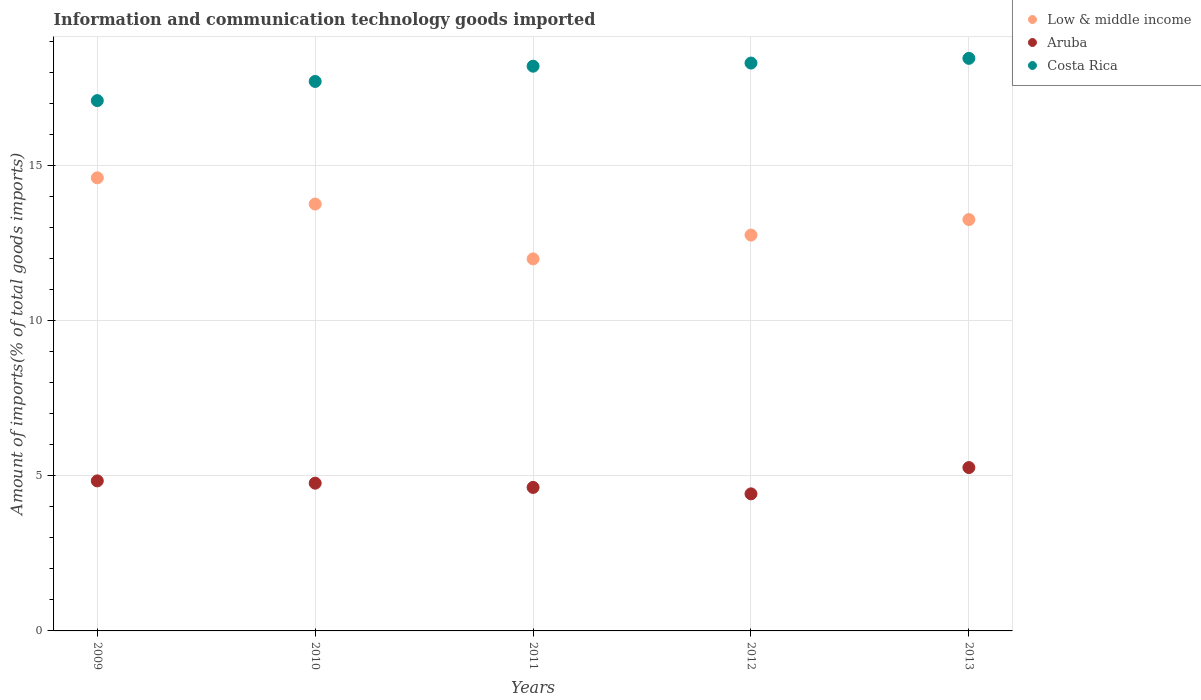How many different coloured dotlines are there?
Offer a very short reply. 3. Is the number of dotlines equal to the number of legend labels?
Your response must be concise. Yes. What is the amount of goods imported in Low & middle income in 2011?
Provide a succinct answer. 12. Across all years, what is the maximum amount of goods imported in Low & middle income?
Ensure brevity in your answer.  14.61. Across all years, what is the minimum amount of goods imported in Low & middle income?
Keep it short and to the point. 12. What is the total amount of goods imported in Aruba in the graph?
Your answer should be compact. 23.92. What is the difference between the amount of goods imported in Costa Rica in 2012 and that in 2013?
Provide a succinct answer. -0.15. What is the difference between the amount of goods imported in Low & middle income in 2011 and the amount of goods imported in Costa Rica in 2010?
Keep it short and to the point. -5.72. What is the average amount of goods imported in Aruba per year?
Provide a short and direct response. 4.78. In the year 2011, what is the difference between the amount of goods imported in Costa Rica and amount of goods imported in Low & middle income?
Your response must be concise. 6.21. In how many years, is the amount of goods imported in Low & middle income greater than 6 %?
Your response must be concise. 5. What is the ratio of the amount of goods imported in Low & middle income in 2009 to that in 2013?
Make the answer very short. 1.1. What is the difference between the highest and the second highest amount of goods imported in Costa Rica?
Your answer should be very brief. 0.15. What is the difference between the highest and the lowest amount of goods imported in Low & middle income?
Ensure brevity in your answer.  2.61. In how many years, is the amount of goods imported in Aruba greater than the average amount of goods imported in Aruba taken over all years?
Offer a terse response. 2. Is the sum of the amount of goods imported in Aruba in 2009 and 2010 greater than the maximum amount of goods imported in Costa Rica across all years?
Keep it short and to the point. No. Does the amount of goods imported in Low & middle income monotonically increase over the years?
Offer a very short reply. No. What is the difference between two consecutive major ticks on the Y-axis?
Make the answer very short. 5. Does the graph contain any zero values?
Your answer should be very brief. No. Does the graph contain grids?
Offer a terse response. Yes. Where does the legend appear in the graph?
Your response must be concise. Top right. What is the title of the graph?
Ensure brevity in your answer.  Information and communication technology goods imported. What is the label or title of the Y-axis?
Your response must be concise. Amount of imports(% of total goods imports). What is the Amount of imports(% of total goods imports) of Low & middle income in 2009?
Your response must be concise. 14.61. What is the Amount of imports(% of total goods imports) in Aruba in 2009?
Your response must be concise. 4.84. What is the Amount of imports(% of total goods imports) of Costa Rica in 2009?
Your response must be concise. 17.1. What is the Amount of imports(% of total goods imports) in Low & middle income in 2010?
Your answer should be compact. 13.77. What is the Amount of imports(% of total goods imports) of Aruba in 2010?
Your answer should be compact. 4.76. What is the Amount of imports(% of total goods imports) of Costa Rica in 2010?
Ensure brevity in your answer.  17.72. What is the Amount of imports(% of total goods imports) of Low & middle income in 2011?
Your answer should be very brief. 12. What is the Amount of imports(% of total goods imports) of Aruba in 2011?
Your answer should be compact. 4.63. What is the Amount of imports(% of total goods imports) of Costa Rica in 2011?
Your answer should be compact. 18.21. What is the Amount of imports(% of total goods imports) of Low & middle income in 2012?
Your answer should be very brief. 12.77. What is the Amount of imports(% of total goods imports) in Aruba in 2012?
Your answer should be compact. 4.42. What is the Amount of imports(% of total goods imports) of Costa Rica in 2012?
Your answer should be compact. 18.31. What is the Amount of imports(% of total goods imports) in Low & middle income in 2013?
Give a very brief answer. 13.27. What is the Amount of imports(% of total goods imports) in Aruba in 2013?
Make the answer very short. 5.27. What is the Amount of imports(% of total goods imports) of Costa Rica in 2013?
Keep it short and to the point. 18.47. Across all years, what is the maximum Amount of imports(% of total goods imports) of Low & middle income?
Your response must be concise. 14.61. Across all years, what is the maximum Amount of imports(% of total goods imports) of Aruba?
Your answer should be compact. 5.27. Across all years, what is the maximum Amount of imports(% of total goods imports) in Costa Rica?
Your response must be concise. 18.47. Across all years, what is the minimum Amount of imports(% of total goods imports) in Low & middle income?
Make the answer very short. 12. Across all years, what is the minimum Amount of imports(% of total goods imports) of Aruba?
Ensure brevity in your answer.  4.42. Across all years, what is the minimum Amount of imports(% of total goods imports) of Costa Rica?
Provide a short and direct response. 17.1. What is the total Amount of imports(% of total goods imports) in Low & middle income in the graph?
Make the answer very short. 66.41. What is the total Amount of imports(% of total goods imports) in Aruba in the graph?
Offer a terse response. 23.92. What is the total Amount of imports(% of total goods imports) in Costa Rica in the graph?
Your answer should be very brief. 89.82. What is the difference between the Amount of imports(% of total goods imports) of Low & middle income in 2009 and that in 2010?
Ensure brevity in your answer.  0.85. What is the difference between the Amount of imports(% of total goods imports) in Aruba in 2009 and that in 2010?
Make the answer very short. 0.07. What is the difference between the Amount of imports(% of total goods imports) in Costa Rica in 2009 and that in 2010?
Give a very brief answer. -0.62. What is the difference between the Amount of imports(% of total goods imports) in Low & middle income in 2009 and that in 2011?
Your answer should be compact. 2.61. What is the difference between the Amount of imports(% of total goods imports) in Aruba in 2009 and that in 2011?
Provide a succinct answer. 0.21. What is the difference between the Amount of imports(% of total goods imports) of Costa Rica in 2009 and that in 2011?
Your answer should be compact. -1.11. What is the difference between the Amount of imports(% of total goods imports) in Low & middle income in 2009 and that in 2012?
Make the answer very short. 1.85. What is the difference between the Amount of imports(% of total goods imports) of Aruba in 2009 and that in 2012?
Ensure brevity in your answer.  0.42. What is the difference between the Amount of imports(% of total goods imports) in Costa Rica in 2009 and that in 2012?
Give a very brief answer. -1.21. What is the difference between the Amount of imports(% of total goods imports) in Low & middle income in 2009 and that in 2013?
Your answer should be compact. 1.35. What is the difference between the Amount of imports(% of total goods imports) of Aruba in 2009 and that in 2013?
Ensure brevity in your answer.  -0.43. What is the difference between the Amount of imports(% of total goods imports) in Costa Rica in 2009 and that in 2013?
Your answer should be compact. -1.36. What is the difference between the Amount of imports(% of total goods imports) of Low & middle income in 2010 and that in 2011?
Provide a short and direct response. 1.77. What is the difference between the Amount of imports(% of total goods imports) of Aruba in 2010 and that in 2011?
Your answer should be compact. 0.14. What is the difference between the Amount of imports(% of total goods imports) in Costa Rica in 2010 and that in 2011?
Offer a terse response. -0.49. What is the difference between the Amount of imports(% of total goods imports) in Low & middle income in 2010 and that in 2012?
Keep it short and to the point. 1. What is the difference between the Amount of imports(% of total goods imports) in Aruba in 2010 and that in 2012?
Provide a short and direct response. 0.34. What is the difference between the Amount of imports(% of total goods imports) of Costa Rica in 2010 and that in 2012?
Ensure brevity in your answer.  -0.59. What is the difference between the Amount of imports(% of total goods imports) of Low & middle income in 2010 and that in 2013?
Keep it short and to the point. 0.5. What is the difference between the Amount of imports(% of total goods imports) in Aruba in 2010 and that in 2013?
Provide a succinct answer. -0.5. What is the difference between the Amount of imports(% of total goods imports) in Costa Rica in 2010 and that in 2013?
Your answer should be very brief. -0.74. What is the difference between the Amount of imports(% of total goods imports) of Low & middle income in 2011 and that in 2012?
Your answer should be compact. -0.77. What is the difference between the Amount of imports(% of total goods imports) in Aruba in 2011 and that in 2012?
Your response must be concise. 0.21. What is the difference between the Amount of imports(% of total goods imports) of Costa Rica in 2011 and that in 2012?
Offer a terse response. -0.1. What is the difference between the Amount of imports(% of total goods imports) in Low & middle income in 2011 and that in 2013?
Provide a succinct answer. -1.27. What is the difference between the Amount of imports(% of total goods imports) in Aruba in 2011 and that in 2013?
Your response must be concise. -0.64. What is the difference between the Amount of imports(% of total goods imports) in Costa Rica in 2011 and that in 2013?
Your answer should be compact. -0.25. What is the difference between the Amount of imports(% of total goods imports) in Low & middle income in 2012 and that in 2013?
Offer a very short reply. -0.5. What is the difference between the Amount of imports(% of total goods imports) in Aruba in 2012 and that in 2013?
Provide a short and direct response. -0.85. What is the difference between the Amount of imports(% of total goods imports) of Costa Rica in 2012 and that in 2013?
Offer a very short reply. -0.15. What is the difference between the Amount of imports(% of total goods imports) of Low & middle income in 2009 and the Amount of imports(% of total goods imports) of Aruba in 2010?
Provide a short and direct response. 9.85. What is the difference between the Amount of imports(% of total goods imports) of Low & middle income in 2009 and the Amount of imports(% of total goods imports) of Costa Rica in 2010?
Provide a short and direct response. -3.11. What is the difference between the Amount of imports(% of total goods imports) of Aruba in 2009 and the Amount of imports(% of total goods imports) of Costa Rica in 2010?
Offer a very short reply. -12.88. What is the difference between the Amount of imports(% of total goods imports) of Low & middle income in 2009 and the Amount of imports(% of total goods imports) of Aruba in 2011?
Provide a succinct answer. 9.99. What is the difference between the Amount of imports(% of total goods imports) in Low & middle income in 2009 and the Amount of imports(% of total goods imports) in Costa Rica in 2011?
Provide a short and direct response. -3.6. What is the difference between the Amount of imports(% of total goods imports) in Aruba in 2009 and the Amount of imports(% of total goods imports) in Costa Rica in 2011?
Ensure brevity in your answer.  -13.37. What is the difference between the Amount of imports(% of total goods imports) in Low & middle income in 2009 and the Amount of imports(% of total goods imports) in Aruba in 2012?
Offer a terse response. 10.19. What is the difference between the Amount of imports(% of total goods imports) in Low & middle income in 2009 and the Amount of imports(% of total goods imports) in Costa Rica in 2012?
Your response must be concise. -3.7. What is the difference between the Amount of imports(% of total goods imports) in Aruba in 2009 and the Amount of imports(% of total goods imports) in Costa Rica in 2012?
Your answer should be very brief. -13.48. What is the difference between the Amount of imports(% of total goods imports) of Low & middle income in 2009 and the Amount of imports(% of total goods imports) of Aruba in 2013?
Keep it short and to the point. 9.34. What is the difference between the Amount of imports(% of total goods imports) of Low & middle income in 2009 and the Amount of imports(% of total goods imports) of Costa Rica in 2013?
Give a very brief answer. -3.85. What is the difference between the Amount of imports(% of total goods imports) in Aruba in 2009 and the Amount of imports(% of total goods imports) in Costa Rica in 2013?
Your answer should be very brief. -13.63. What is the difference between the Amount of imports(% of total goods imports) of Low & middle income in 2010 and the Amount of imports(% of total goods imports) of Aruba in 2011?
Give a very brief answer. 9.14. What is the difference between the Amount of imports(% of total goods imports) in Low & middle income in 2010 and the Amount of imports(% of total goods imports) in Costa Rica in 2011?
Keep it short and to the point. -4.45. What is the difference between the Amount of imports(% of total goods imports) of Aruba in 2010 and the Amount of imports(% of total goods imports) of Costa Rica in 2011?
Offer a terse response. -13.45. What is the difference between the Amount of imports(% of total goods imports) in Low & middle income in 2010 and the Amount of imports(% of total goods imports) in Aruba in 2012?
Make the answer very short. 9.35. What is the difference between the Amount of imports(% of total goods imports) of Low & middle income in 2010 and the Amount of imports(% of total goods imports) of Costa Rica in 2012?
Provide a short and direct response. -4.55. What is the difference between the Amount of imports(% of total goods imports) in Aruba in 2010 and the Amount of imports(% of total goods imports) in Costa Rica in 2012?
Your response must be concise. -13.55. What is the difference between the Amount of imports(% of total goods imports) of Low & middle income in 2010 and the Amount of imports(% of total goods imports) of Aruba in 2013?
Give a very brief answer. 8.5. What is the difference between the Amount of imports(% of total goods imports) of Low & middle income in 2010 and the Amount of imports(% of total goods imports) of Costa Rica in 2013?
Your answer should be very brief. -4.7. What is the difference between the Amount of imports(% of total goods imports) in Aruba in 2010 and the Amount of imports(% of total goods imports) in Costa Rica in 2013?
Your answer should be very brief. -13.7. What is the difference between the Amount of imports(% of total goods imports) of Low & middle income in 2011 and the Amount of imports(% of total goods imports) of Aruba in 2012?
Provide a succinct answer. 7.58. What is the difference between the Amount of imports(% of total goods imports) in Low & middle income in 2011 and the Amount of imports(% of total goods imports) in Costa Rica in 2012?
Ensure brevity in your answer.  -6.32. What is the difference between the Amount of imports(% of total goods imports) of Aruba in 2011 and the Amount of imports(% of total goods imports) of Costa Rica in 2012?
Ensure brevity in your answer.  -13.69. What is the difference between the Amount of imports(% of total goods imports) in Low & middle income in 2011 and the Amount of imports(% of total goods imports) in Aruba in 2013?
Provide a short and direct response. 6.73. What is the difference between the Amount of imports(% of total goods imports) in Low & middle income in 2011 and the Amount of imports(% of total goods imports) in Costa Rica in 2013?
Provide a succinct answer. -6.47. What is the difference between the Amount of imports(% of total goods imports) of Aruba in 2011 and the Amount of imports(% of total goods imports) of Costa Rica in 2013?
Provide a short and direct response. -13.84. What is the difference between the Amount of imports(% of total goods imports) in Low & middle income in 2012 and the Amount of imports(% of total goods imports) in Aruba in 2013?
Your answer should be very brief. 7.5. What is the difference between the Amount of imports(% of total goods imports) in Low & middle income in 2012 and the Amount of imports(% of total goods imports) in Costa Rica in 2013?
Give a very brief answer. -5.7. What is the difference between the Amount of imports(% of total goods imports) in Aruba in 2012 and the Amount of imports(% of total goods imports) in Costa Rica in 2013?
Make the answer very short. -14.05. What is the average Amount of imports(% of total goods imports) in Low & middle income per year?
Give a very brief answer. 13.28. What is the average Amount of imports(% of total goods imports) in Aruba per year?
Provide a short and direct response. 4.78. What is the average Amount of imports(% of total goods imports) in Costa Rica per year?
Keep it short and to the point. 17.96. In the year 2009, what is the difference between the Amount of imports(% of total goods imports) in Low & middle income and Amount of imports(% of total goods imports) in Aruba?
Offer a terse response. 9.77. In the year 2009, what is the difference between the Amount of imports(% of total goods imports) of Low & middle income and Amount of imports(% of total goods imports) of Costa Rica?
Ensure brevity in your answer.  -2.49. In the year 2009, what is the difference between the Amount of imports(% of total goods imports) in Aruba and Amount of imports(% of total goods imports) in Costa Rica?
Provide a succinct answer. -12.26. In the year 2010, what is the difference between the Amount of imports(% of total goods imports) of Low & middle income and Amount of imports(% of total goods imports) of Aruba?
Provide a succinct answer. 9. In the year 2010, what is the difference between the Amount of imports(% of total goods imports) in Low & middle income and Amount of imports(% of total goods imports) in Costa Rica?
Keep it short and to the point. -3.95. In the year 2010, what is the difference between the Amount of imports(% of total goods imports) of Aruba and Amount of imports(% of total goods imports) of Costa Rica?
Provide a succinct answer. -12.96. In the year 2011, what is the difference between the Amount of imports(% of total goods imports) in Low & middle income and Amount of imports(% of total goods imports) in Aruba?
Offer a terse response. 7.37. In the year 2011, what is the difference between the Amount of imports(% of total goods imports) of Low & middle income and Amount of imports(% of total goods imports) of Costa Rica?
Your response must be concise. -6.21. In the year 2011, what is the difference between the Amount of imports(% of total goods imports) in Aruba and Amount of imports(% of total goods imports) in Costa Rica?
Offer a terse response. -13.59. In the year 2012, what is the difference between the Amount of imports(% of total goods imports) of Low & middle income and Amount of imports(% of total goods imports) of Aruba?
Offer a very short reply. 8.35. In the year 2012, what is the difference between the Amount of imports(% of total goods imports) of Low & middle income and Amount of imports(% of total goods imports) of Costa Rica?
Your answer should be very brief. -5.55. In the year 2012, what is the difference between the Amount of imports(% of total goods imports) in Aruba and Amount of imports(% of total goods imports) in Costa Rica?
Provide a succinct answer. -13.89. In the year 2013, what is the difference between the Amount of imports(% of total goods imports) in Low & middle income and Amount of imports(% of total goods imports) in Aruba?
Give a very brief answer. 8. In the year 2013, what is the difference between the Amount of imports(% of total goods imports) of Low & middle income and Amount of imports(% of total goods imports) of Costa Rica?
Provide a short and direct response. -5.2. In the year 2013, what is the difference between the Amount of imports(% of total goods imports) of Aruba and Amount of imports(% of total goods imports) of Costa Rica?
Offer a very short reply. -13.2. What is the ratio of the Amount of imports(% of total goods imports) of Low & middle income in 2009 to that in 2010?
Offer a very short reply. 1.06. What is the ratio of the Amount of imports(% of total goods imports) in Aruba in 2009 to that in 2010?
Make the answer very short. 1.02. What is the ratio of the Amount of imports(% of total goods imports) of Costa Rica in 2009 to that in 2010?
Your answer should be very brief. 0.97. What is the ratio of the Amount of imports(% of total goods imports) of Low & middle income in 2009 to that in 2011?
Ensure brevity in your answer.  1.22. What is the ratio of the Amount of imports(% of total goods imports) in Aruba in 2009 to that in 2011?
Give a very brief answer. 1.05. What is the ratio of the Amount of imports(% of total goods imports) in Costa Rica in 2009 to that in 2011?
Offer a very short reply. 0.94. What is the ratio of the Amount of imports(% of total goods imports) in Low & middle income in 2009 to that in 2012?
Give a very brief answer. 1.14. What is the ratio of the Amount of imports(% of total goods imports) in Aruba in 2009 to that in 2012?
Your answer should be compact. 1.09. What is the ratio of the Amount of imports(% of total goods imports) in Costa Rica in 2009 to that in 2012?
Your answer should be compact. 0.93. What is the ratio of the Amount of imports(% of total goods imports) of Low & middle income in 2009 to that in 2013?
Give a very brief answer. 1.1. What is the ratio of the Amount of imports(% of total goods imports) in Aruba in 2009 to that in 2013?
Your response must be concise. 0.92. What is the ratio of the Amount of imports(% of total goods imports) of Costa Rica in 2009 to that in 2013?
Ensure brevity in your answer.  0.93. What is the ratio of the Amount of imports(% of total goods imports) in Low & middle income in 2010 to that in 2011?
Your answer should be compact. 1.15. What is the ratio of the Amount of imports(% of total goods imports) in Aruba in 2010 to that in 2011?
Give a very brief answer. 1.03. What is the ratio of the Amount of imports(% of total goods imports) of Costa Rica in 2010 to that in 2011?
Your answer should be compact. 0.97. What is the ratio of the Amount of imports(% of total goods imports) of Low & middle income in 2010 to that in 2012?
Your answer should be compact. 1.08. What is the ratio of the Amount of imports(% of total goods imports) of Aruba in 2010 to that in 2012?
Offer a terse response. 1.08. What is the ratio of the Amount of imports(% of total goods imports) of Costa Rica in 2010 to that in 2012?
Give a very brief answer. 0.97. What is the ratio of the Amount of imports(% of total goods imports) of Low & middle income in 2010 to that in 2013?
Keep it short and to the point. 1.04. What is the ratio of the Amount of imports(% of total goods imports) in Aruba in 2010 to that in 2013?
Give a very brief answer. 0.9. What is the ratio of the Amount of imports(% of total goods imports) in Costa Rica in 2010 to that in 2013?
Offer a terse response. 0.96. What is the ratio of the Amount of imports(% of total goods imports) of Low & middle income in 2011 to that in 2012?
Ensure brevity in your answer.  0.94. What is the ratio of the Amount of imports(% of total goods imports) of Aruba in 2011 to that in 2012?
Make the answer very short. 1.05. What is the ratio of the Amount of imports(% of total goods imports) of Costa Rica in 2011 to that in 2012?
Provide a short and direct response. 0.99. What is the ratio of the Amount of imports(% of total goods imports) of Low & middle income in 2011 to that in 2013?
Ensure brevity in your answer.  0.9. What is the ratio of the Amount of imports(% of total goods imports) of Aruba in 2011 to that in 2013?
Offer a very short reply. 0.88. What is the ratio of the Amount of imports(% of total goods imports) of Costa Rica in 2011 to that in 2013?
Provide a succinct answer. 0.99. What is the ratio of the Amount of imports(% of total goods imports) of Low & middle income in 2012 to that in 2013?
Your response must be concise. 0.96. What is the ratio of the Amount of imports(% of total goods imports) of Aruba in 2012 to that in 2013?
Your answer should be compact. 0.84. What is the ratio of the Amount of imports(% of total goods imports) in Costa Rica in 2012 to that in 2013?
Provide a succinct answer. 0.99. What is the difference between the highest and the second highest Amount of imports(% of total goods imports) in Low & middle income?
Your answer should be very brief. 0.85. What is the difference between the highest and the second highest Amount of imports(% of total goods imports) of Aruba?
Keep it short and to the point. 0.43. What is the difference between the highest and the second highest Amount of imports(% of total goods imports) in Costa Rica?
Provide a short and direct response. 0.15. What is the difference between the highest and the lowest Amount of imports(% of total goods imports) of Low & middle income?
Your answer should be very brief. 2.61. What is the difference between the highest and the lowest Amount of imports(% of total goods imports) in Aruba?
Provide a short and direct response. 0.85. What is the difference between the highest and the lowest Amount of imports(% of total goods imports) in Costa Rica?
Give a very brief answer. 1.36. 